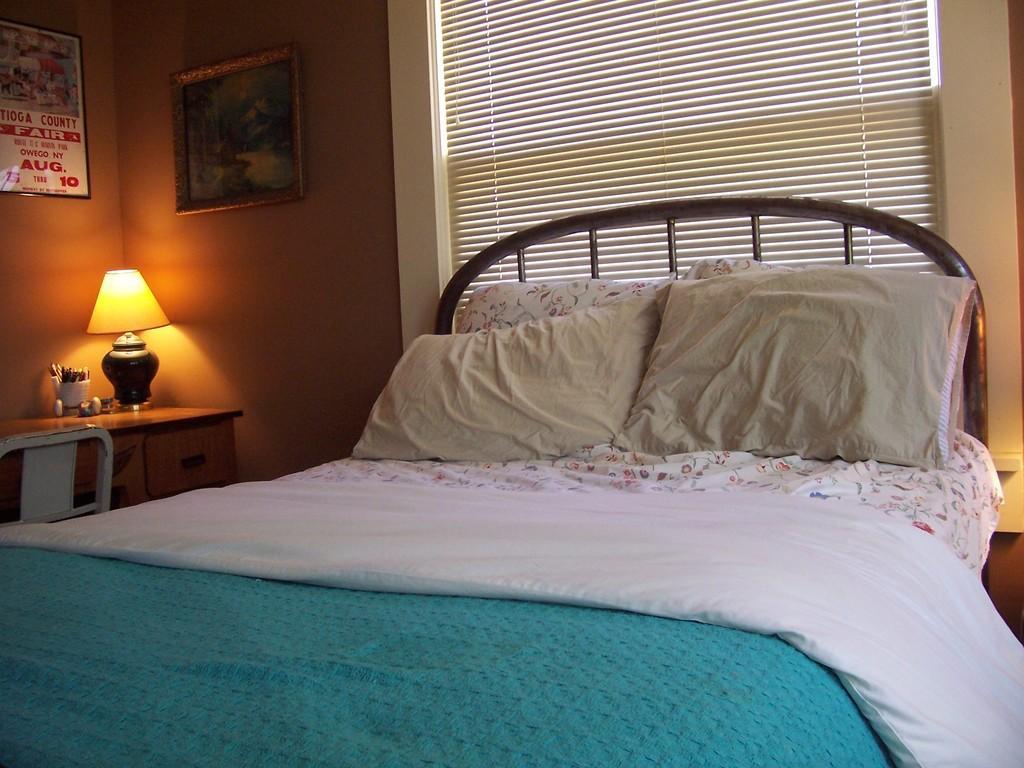In one or two sentences, can you explain what this image depicts? In the center we can see bed on bed there is a blanket and two pillows. In the background there is a wall,window,photo frame,table,chair,pens,headphones and lamp. 